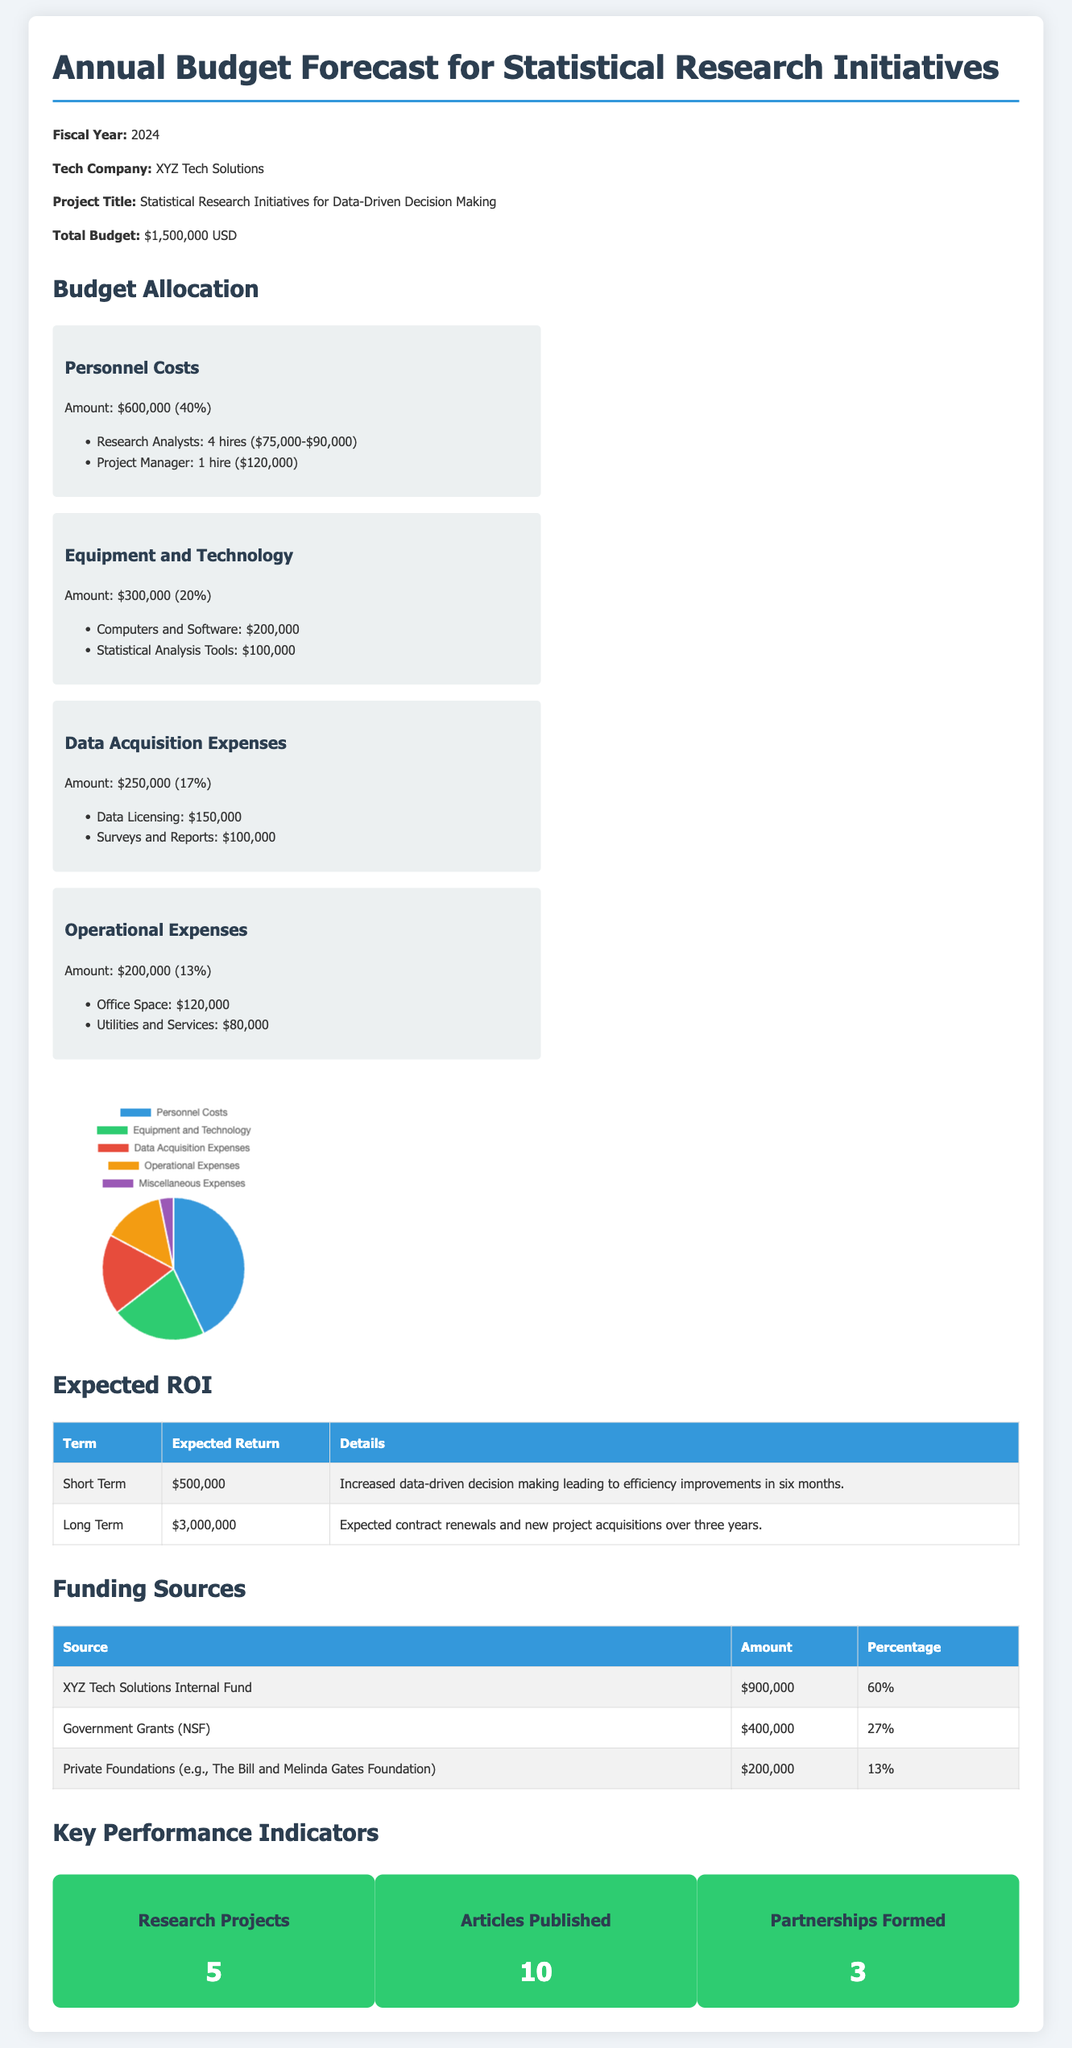What is the total budget for the statistical research initiatives? The total budget is listed in the document as $1,500,000 USD.
Answer: $1,500,000 USD How many research analysts will be hired? The document specifies four research analysts will be hired at salaries ranging from $75,000 to $90,000.
Answer: 4 What percentage of the budget is allocated for equipment and technology? The document states that equipment and technology account for 20% of the total budget.
Answer: 20% What is the expected return in the short term? The document indicates that the expected return in the short term is $500,000.
Answer: $500,000 Which funding source contributes the most to the budget? The document shows that XYZ Tech Solutions Internal Fund contributes $900,000, which is the highest amount among the listed sources.
Answer: XYZ Tech Solutions Internal Fund How many articles are projected to be published? The document reports that 10 articles are expected to be published under this initiative.
Answer: 10 What is the total expected return over the long term? According to the document, the expected return over the long term is $3,000,000.
Answer: $3,000,000 What are the operational expenses amounting to? The document cites the operational expenses as $200,000.
Answer: $200,000 How many partnerships are anticipated to be formed? The document details that 3 partnerships are expected to be formed.
Answer: 3 